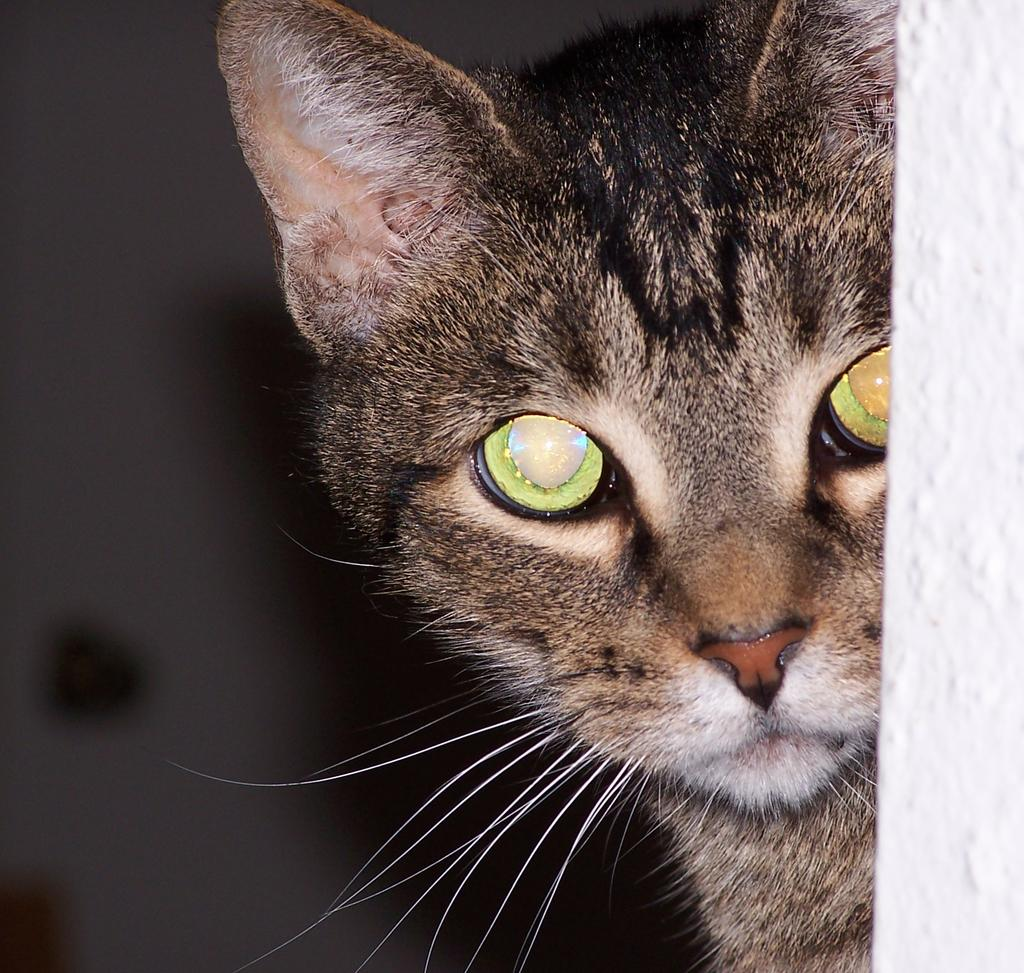What type of animal is in the image? There is a cat in the image. What is located on the right side of the image? There is a wall on the right side of the image. How would you describe the background of the image? The background of the image is blurred. What type of tooth is visible in the image? There is no tooth visible in the image; it features a cat and a wall. Can you tell me what kind of guitar is being played in the image? There is no guitar present in the image; it only shows a cat and a wall. 